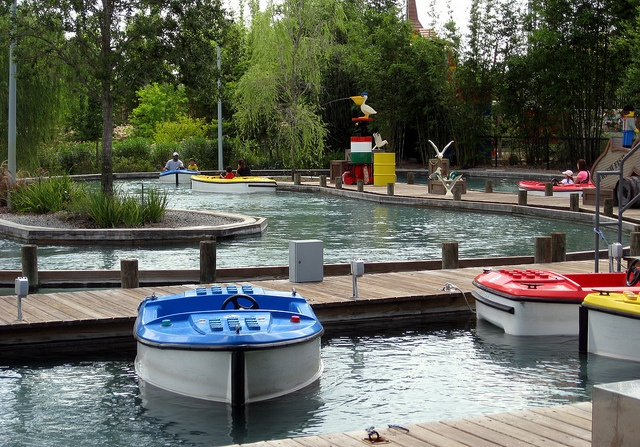Describe the objects in this image and their specific colors. I can see boat in black, darkgray, gray, and lightblue tones, boat in black, darkgray, brown, gray, and salmon tones, boat in black, darkgray, khaki, and gray tones, boat in black, darkgray, lightgray, and khaki tones, and boat in black, salmon, gray, and brown tones in this image. 